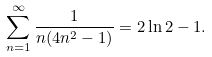<formula> <loc_0><loc_0><loc_500><loc_500>\sum _ { n = 1 } ^ { \infty } { \frac { 1 } { n ( 4 n ^ { 2 } - 1 ) } } = 2 \ln 2 - 1 .</formula> 